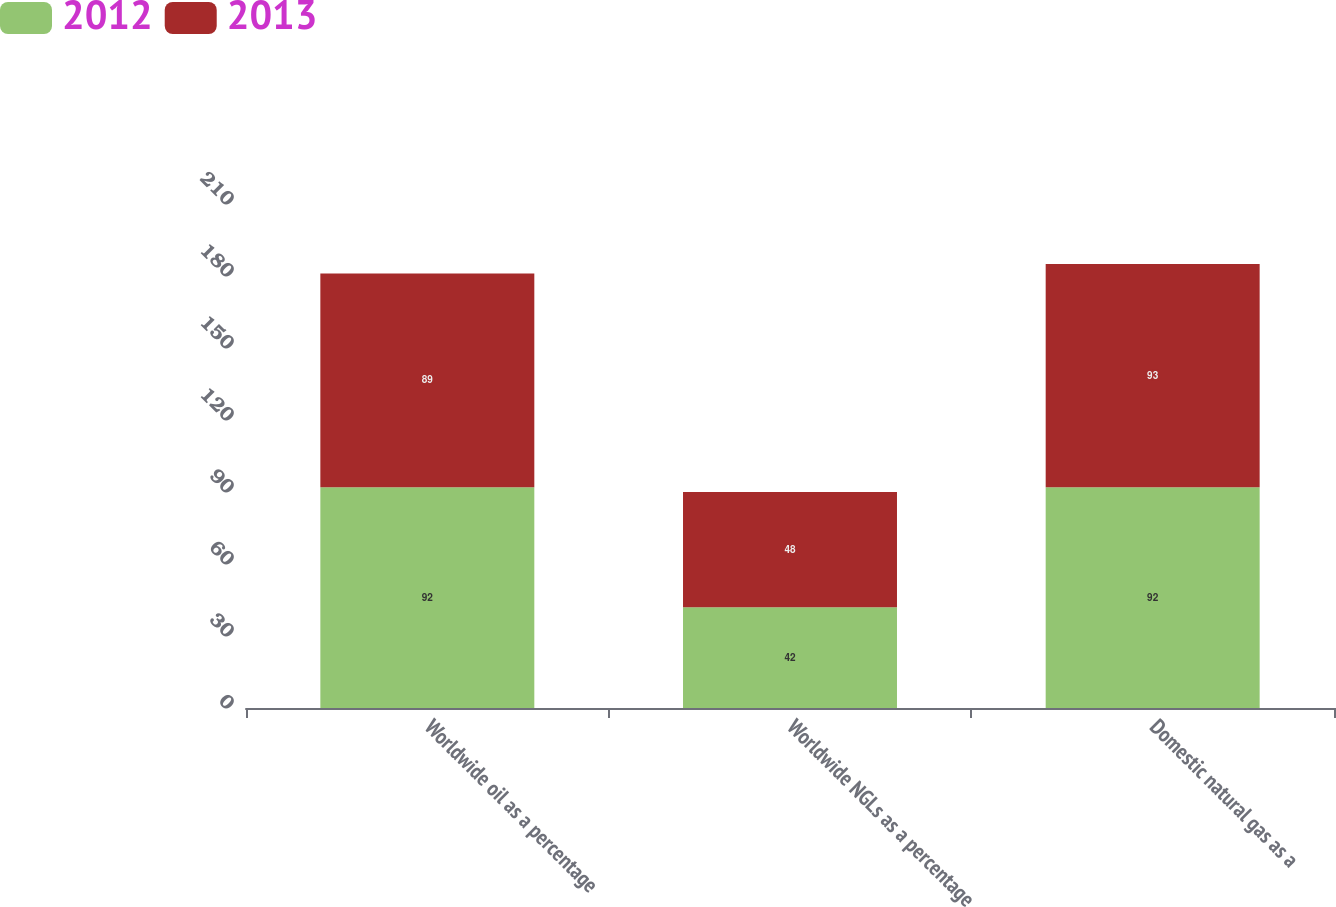Convert chart. <chart><loc_0><loc_0><loc_500><loc_500><stacked_bar_chart><ecel><fcel>Worldwide oil as a percentage<fcel>Worldwide NGLs as a percentage<fcel>Domestic natural gas as a<nl><fcel>2012<fcel>92<fcel>42<fcel>92<nl><fcel>2013<fcel>89<fcel>48<fcel>93<nl></chart> 